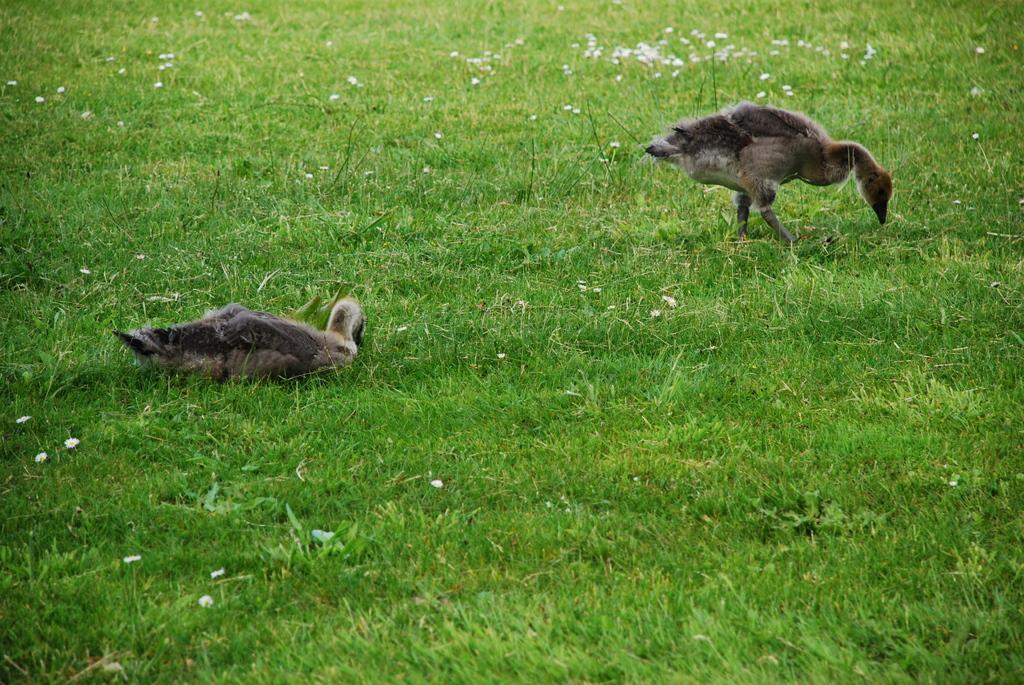How many birds are in the image? There are two birds in the image. What type of natural environment is visible in the image? Grass is present in the image, suggesting a grassy area. What type of fruit can be seen growing on the trees in the image? There are no trees or fruit present in the image; it features two birds and grass. How is the eggnog being used by the birds in the image? There is no eggnog present in the image. 